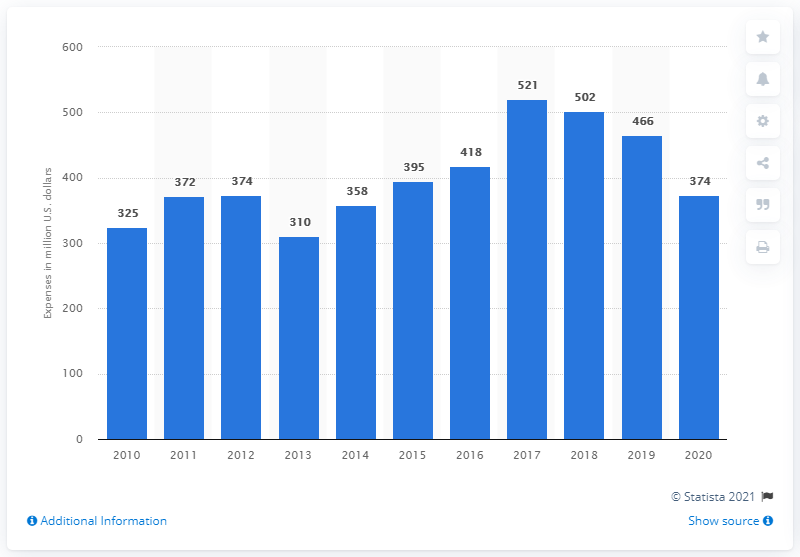How much money did General Dynamics Corporation spend in company-sponsored R&D costs between 2010 and 2020? Over the period from 2010 through 2020, General Dynamics Corporation invested a cumulative total of approximately $4.077 billion in company-sponsored research and development (R&D) costs, based on the annual expenditures shown in the chart. 